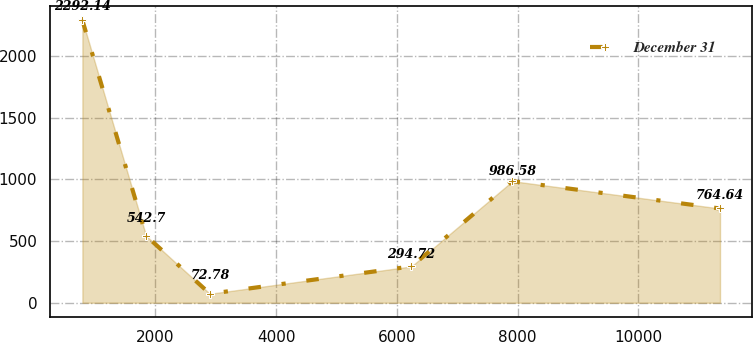Convert chart to OTSL. <chart><loc_0><loc_0><loc_500><loc_500><line_chart><ecel><fcel>December 31<nl><fcel>789.5<fcel>2292.14<nl><fcel>1845.7<fcel>542.7<nl><fcel>2901.9<fcel>72.78<nl><fcel>6240.48<fcel>294.72<nl><fcel>7912.85<fcel>986.58<nl><fcel>11351.5<fcel>764.64<nl></chart> 